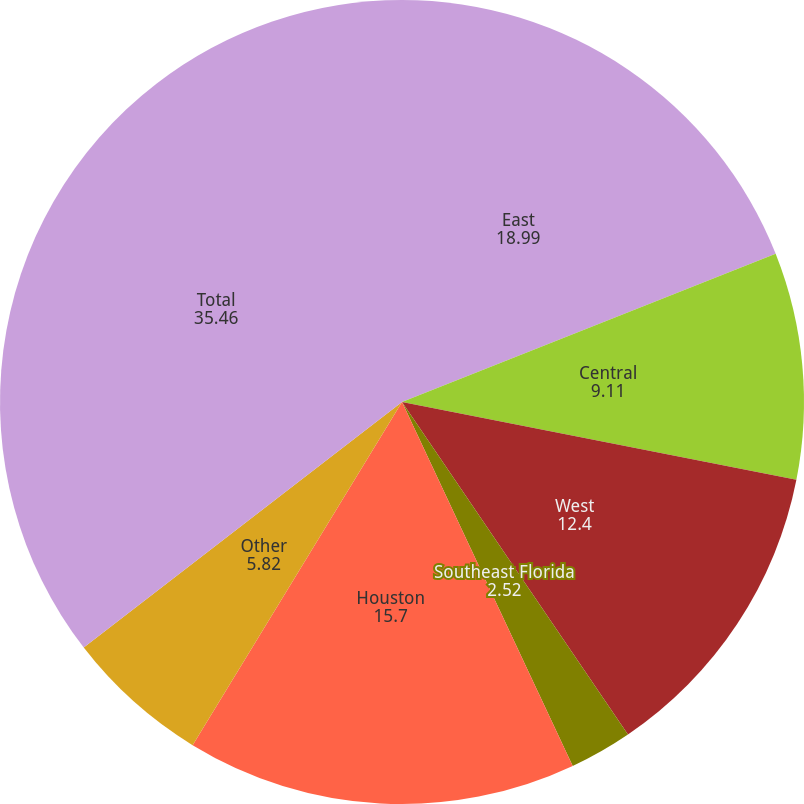<chart> <loc_0><loc_0><loc_500><loc_500><pie_chart><fcel>East<fcel>Central<fcel>West<fcel>Southeast Florida<fcel>Houston<fcel>Other<fcel>Total<nl><fcel>18.99%<fcel>9.11%<fcel>12.4%<fcel>2.52%<fcel>15.7%<fcel>5.82%<fcel>35.46%<nl></chart> 